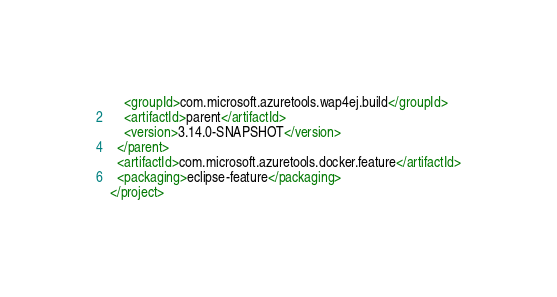<code> <loc_0><loc_0><loc_500><loc_500><_XML_>    <groupId>com.microsoft.azuretools.wap4ej.build</groupId>
    <artifactId>parent</artifactId>
    <version>3.14.0-SNAPSHOT</version>
  </parent>
  <artifactId>com.microsoft.azuretools.docker.feature</artifactId>
  <packaging>eclipse-feature</packaging>
</project>
</code> 